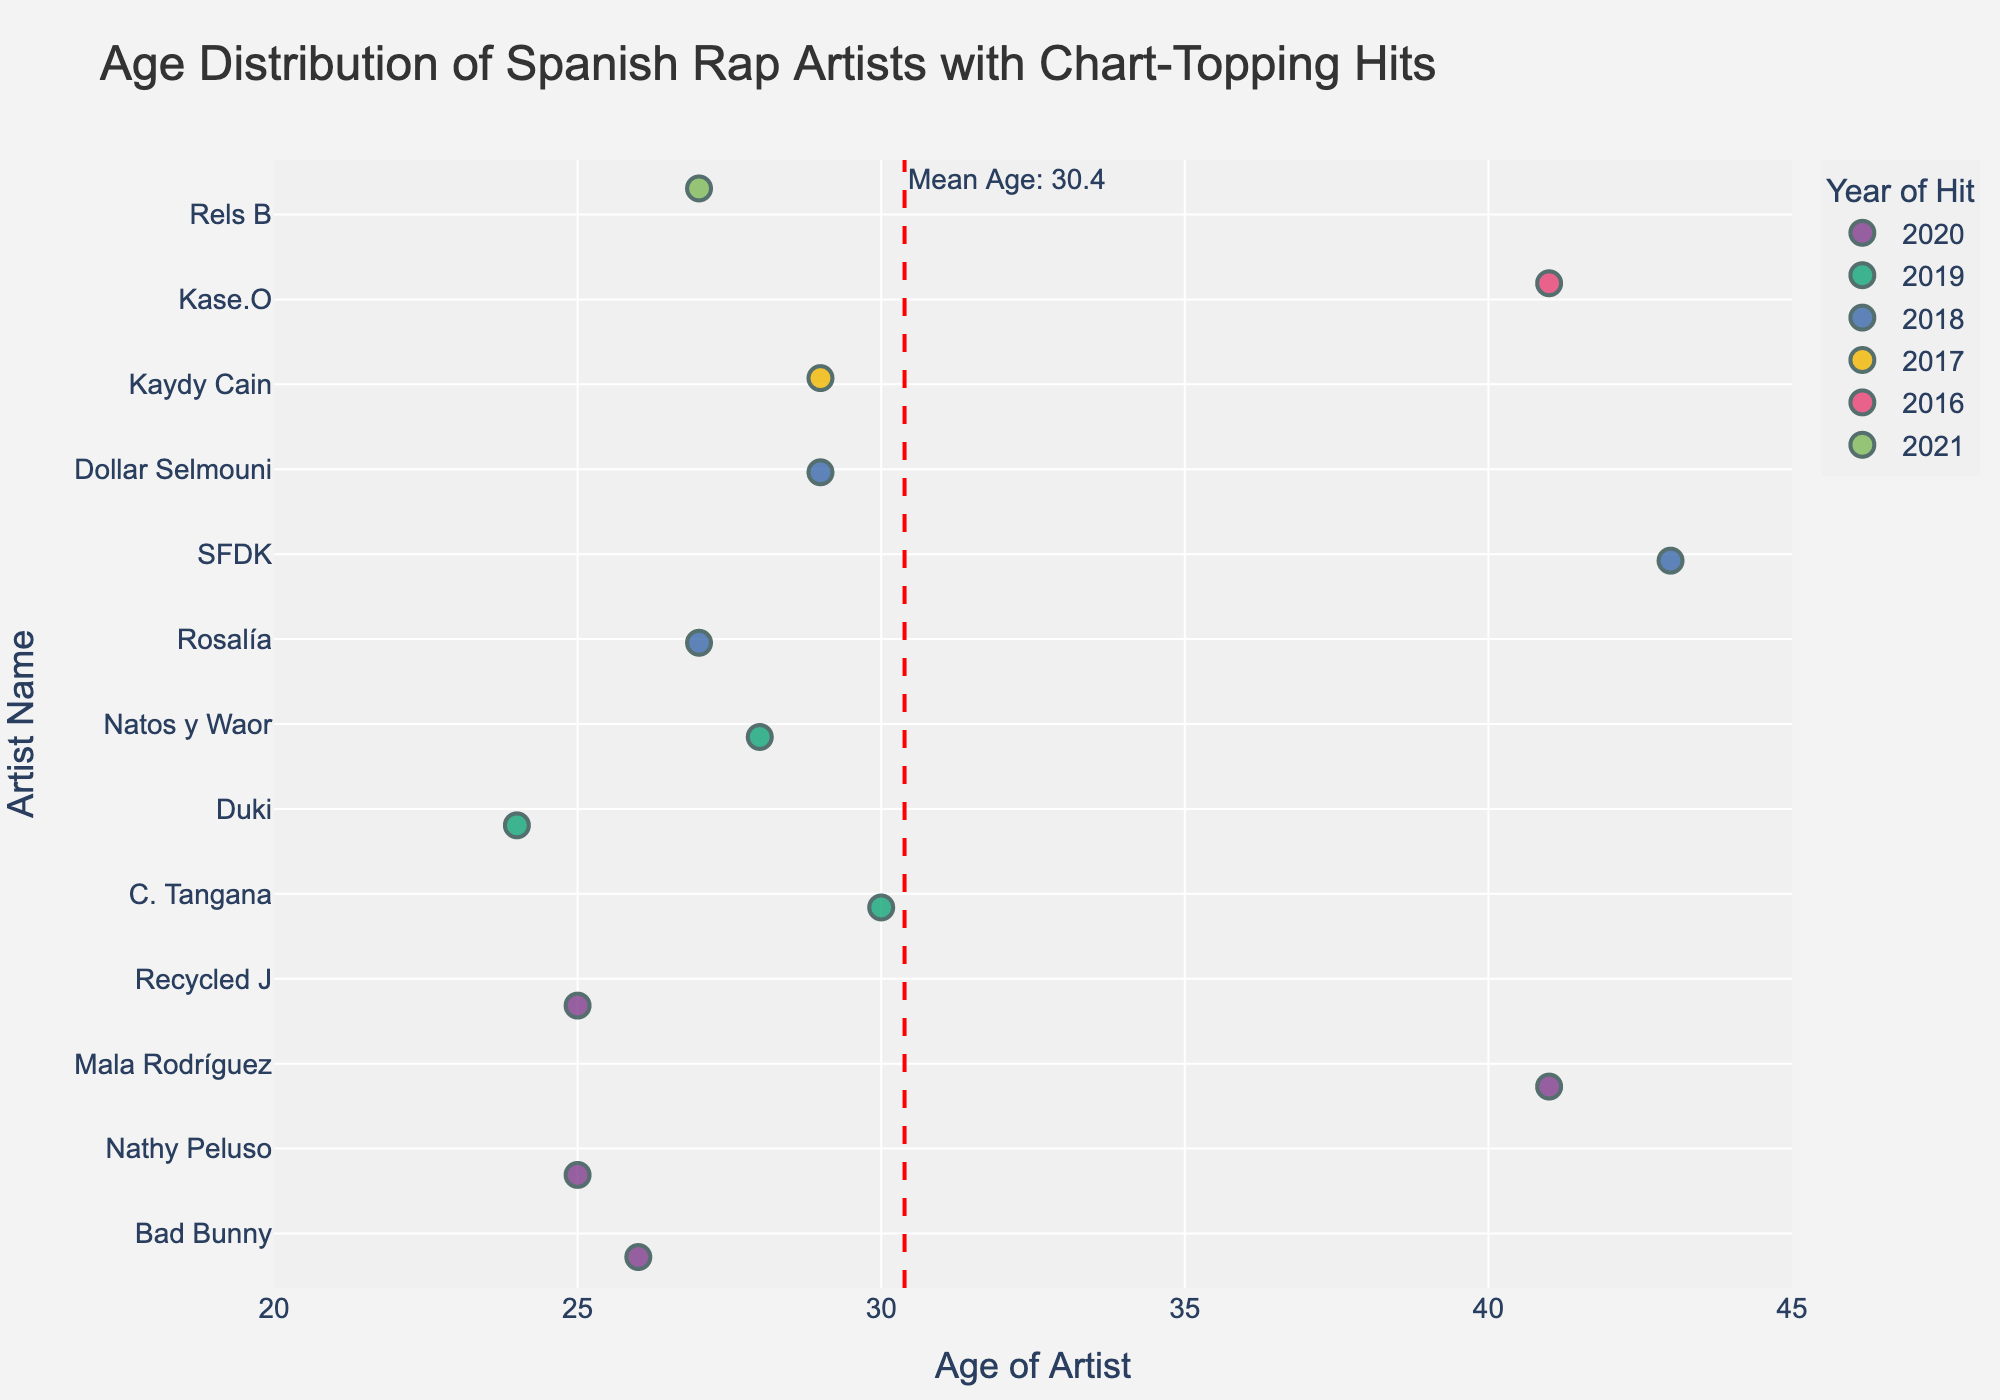What's the general theme captured by the chart? The chart intends to capture the age distribution of Spanish rap artists who had chart-topping hits in the last decade. By plotting age on the x-axis and artist names on the y-axis, it visually represents the artist's age when they achieved chart success.
Answer: The Age Distribution of Spanish Rap Artists What's the range of ages represented in the chart? The ages range from the youngest artist at 24 years old to the oldest artist at 43 years old. The x-axis is labeled accordingly from 20 to 45.
Answer: 24 to 43 years old Who is the youngest artist with a chart-topping hit? By examining the data points, we can find that Duki is the youngest, at the age of 24.
Answer: Duki How many artists achieved chart-topping hits in the year 2020? The color-coded legend helps identify data points from the year 2020. There are 4 artists corresponding to that year.
Answer: 4 What is the mean age of the artists with chart-topping hits? The mean age is indicated by a red dashed vertical line. The annotation next to the line denotes the mean age as approximately 30.3 years.
Answer: 30.3 years Which artist achieved a chart-topping hit at the oldest age? By examining the data points and the artist names, SFDK is shown to have charted at the age of 43.
Answer: SFDK Compare the ages of Bad Bunny and Rosalía when they achieved their hits. Who was older, and by how many years? Bad Bunny was 26, while Rosalía was 27. Thus, Rosalía was older by 1 year.
Answer: Rosalía, by 1 year What's the distribution of ages for artists who achieved hits in 2019? Checking the data points for the year 2019, artists' ages are 30 (C. Tangana), 24 (Duki), and 28 (Natos y Waor).
Answer: 24, 28, 30 years Do any artists have the same age listed on the chart? Yes, Mala Rodríguez and Kase.O both made the chart at the age of 41.
Answer: Yes How does the age of Nathy Peluso compare to Recycled J when each had their chart-topping hit? Nathy Peluso was 25, and Recycled J was also 25, making their ages equal when they achieved their hits.
Answer: Same, 25 years 